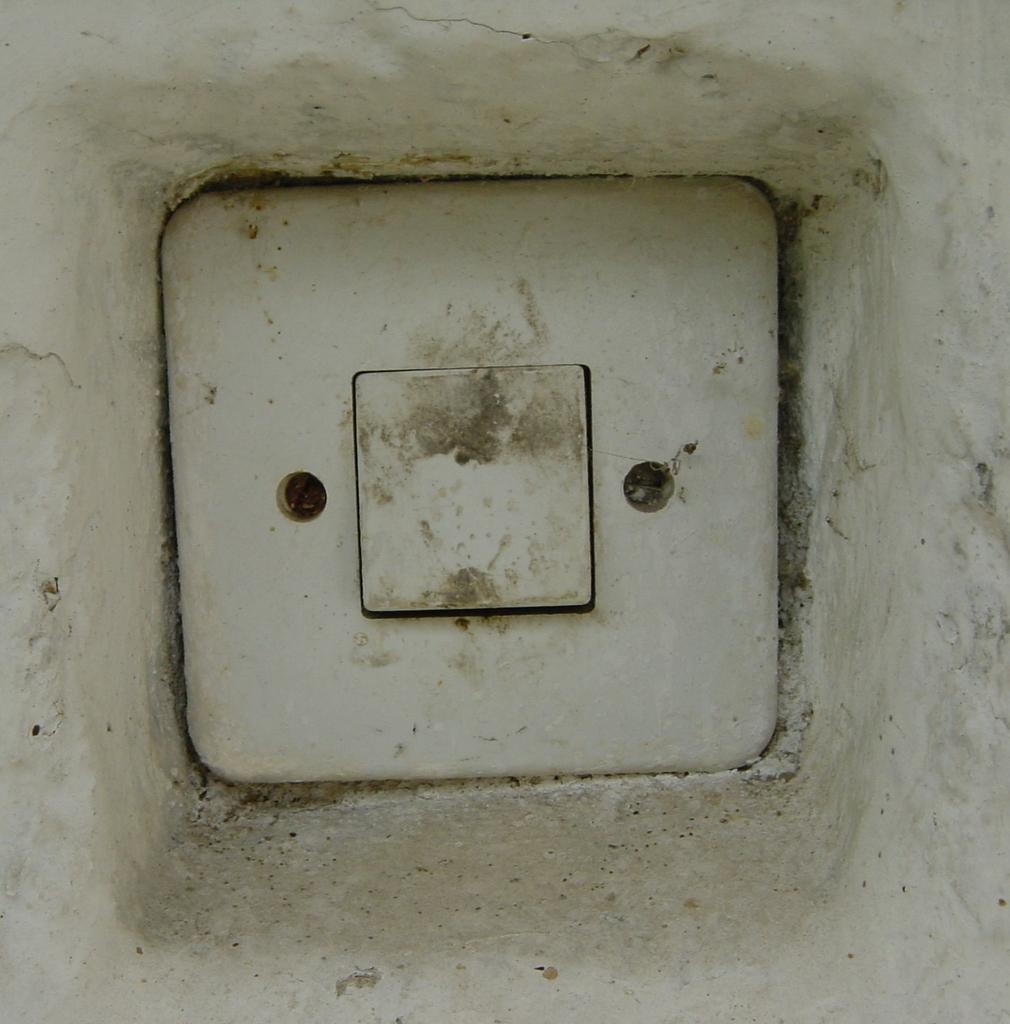Could you give a brief overview of what you see in this image? In this image we can see that there is a switch in the middle. Beside the switch there are two screws. 